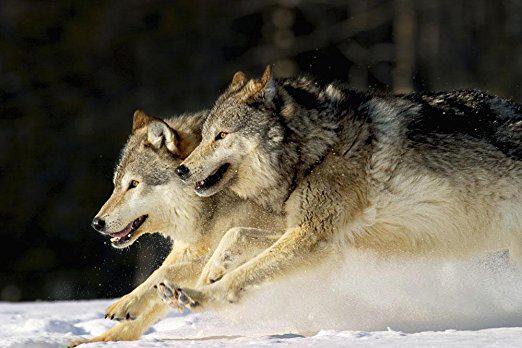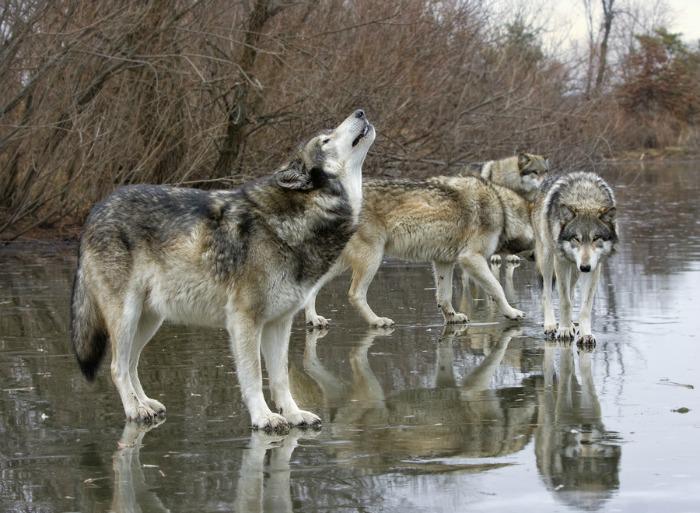The first image is the image on the left, the second image is the image on the right. For the images shown, is this caption "An image includes an open-mouthed snarling wolf." true? Answer yes or no. No. The first image is the image on the left, the second image is the image on the right. Assess this claim about the two images: "The dogs in the image on the left are in a snowy area.". Correct or not? Answer yes or no. Yes. 